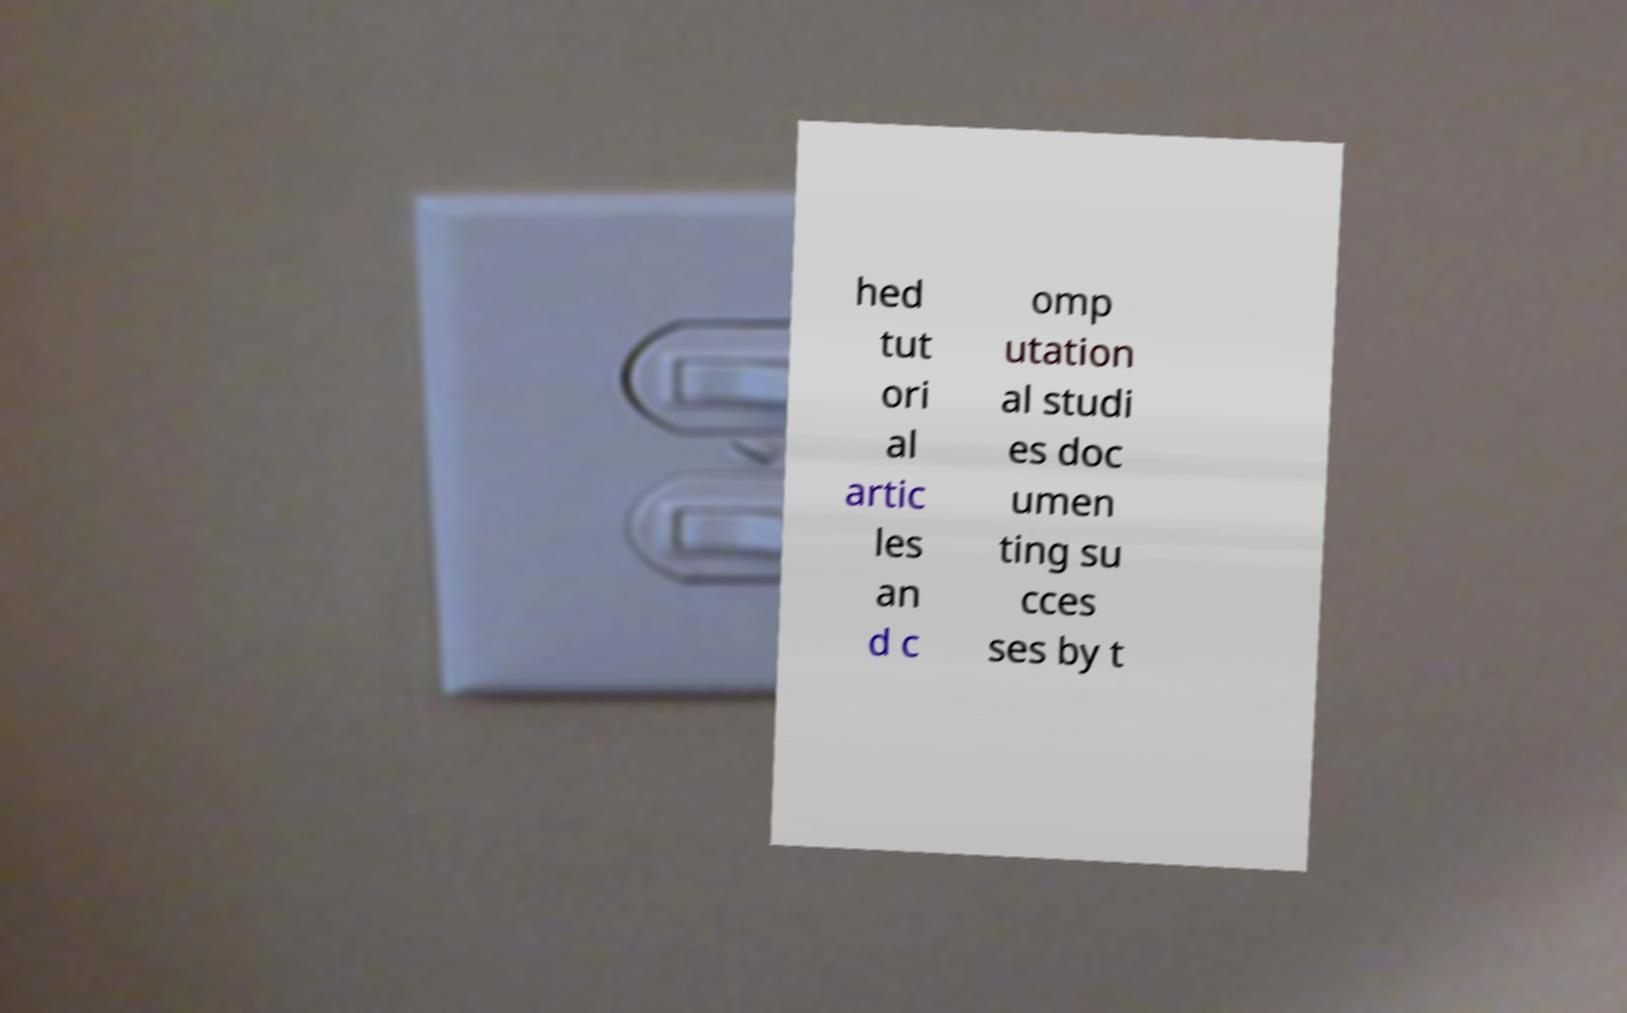Can you read and provide the text displayed in the image?This photo seems to have some interesting text. Can you extract and type it out for me? hed tut ori al artic les an d c omp utation al studi es doc umen ting su cces ses by t 